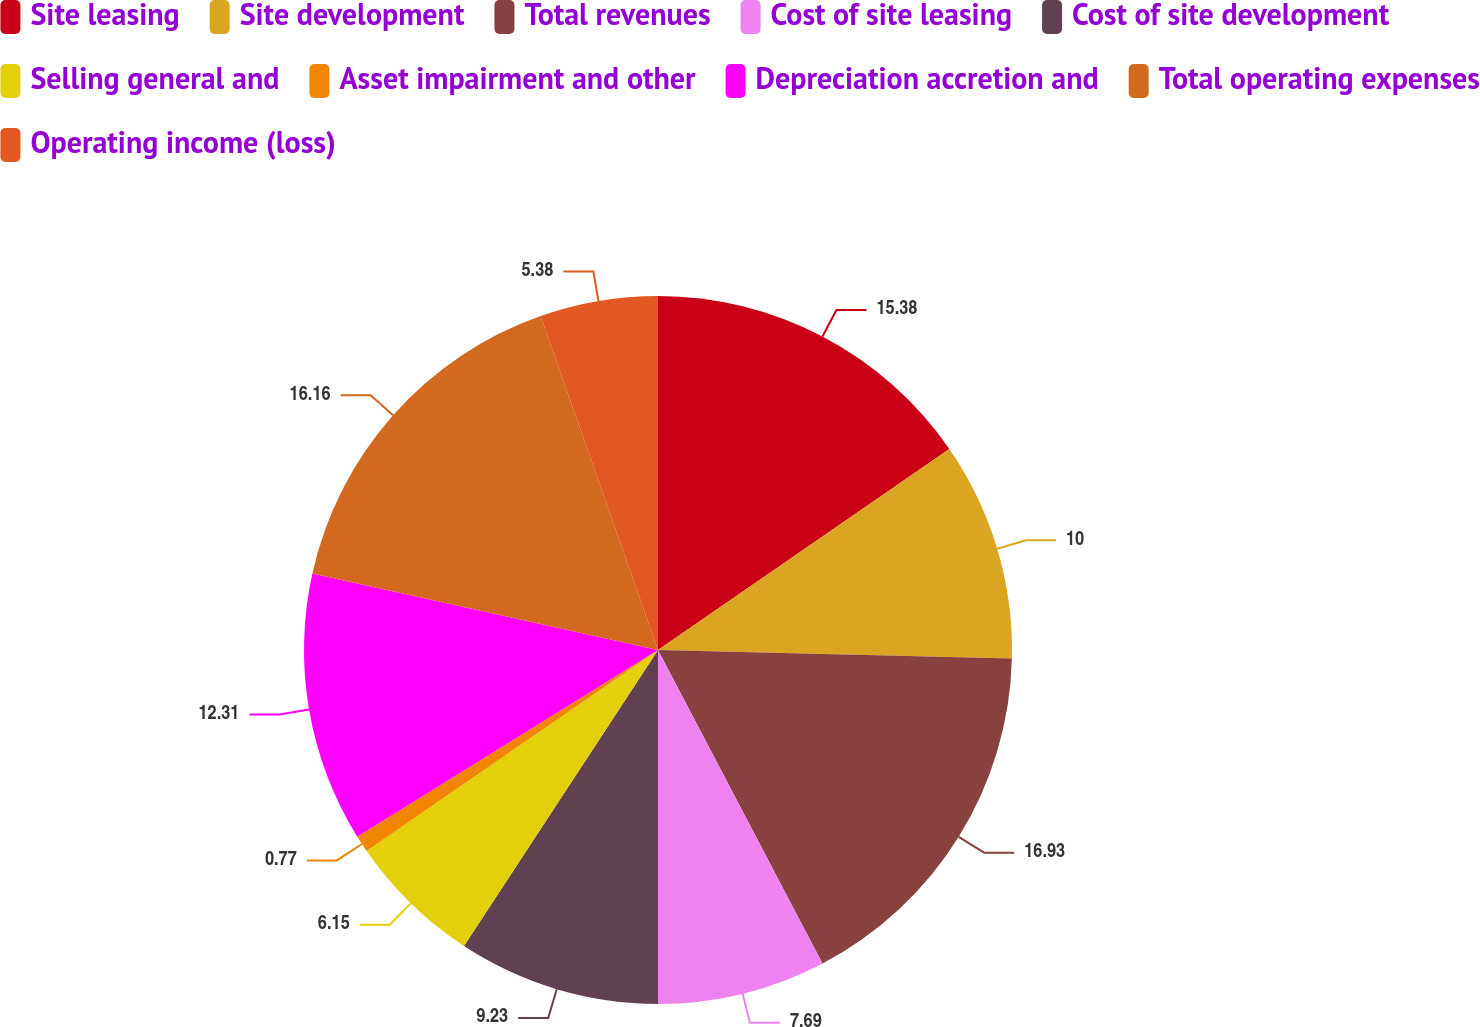Convert chart to OTSL. <chart><loc_0><loc_0><loc_500><loc_500><pie_chart><fcel>Site leasing<fcel>Site development<fcel>Total revenues<fcel>Cost of site leasing<fcel>Cost of site development<fcel>Selling general and<fcel>Asset impairment and other<fcel>Depreciation accretion and<fcel>Total operating expenses<fcel>Operating income (loss)<nl><fcel>15.38%<fcel>10.0%<fcel>16.92%<fcel>7.69%<fcel>9.23%<fcel>6.15%<fcel>0.77%<fcel>12.31%<fcel>16.15%<fcel>5.38%<nl></chart> 